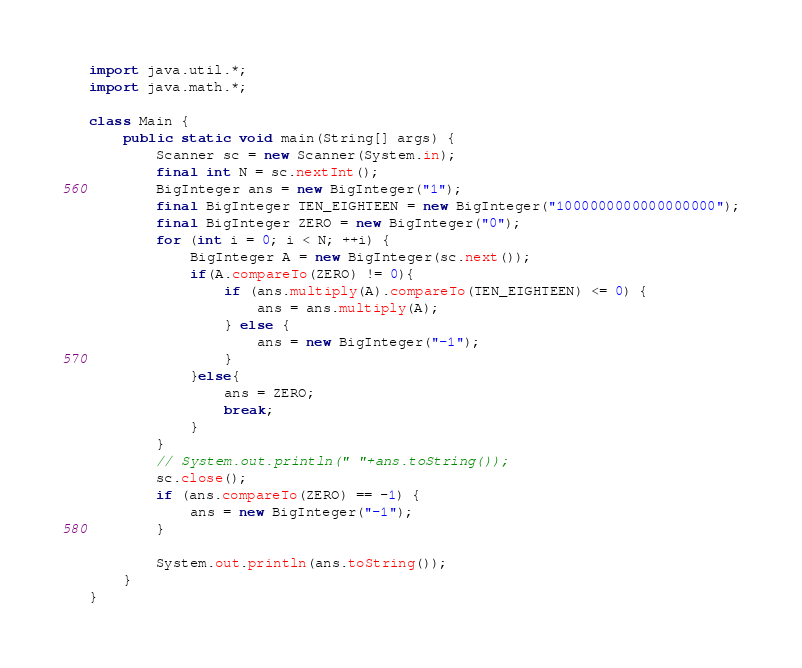Convert code to text. <code><loc_0><loc_0><loc_500><loc_500><_Java_>import java.util.*;
import java.math.*;

class Main {
	public static void main(String[] args) {
		Scanner sc = new Scanner(System.in);
		final int N = sc.nextInt();
		BigInteger ans = new BigInteger("1");
		final BigInteger TEN_EIGHTEEN = new BigInteger("1000000000000000000");
		final BigInteger ZERO = new BigInteger("0");
		for (int i = 0; i < N; ++i) {
			BigInteger A = new BigInteger(sc.next());
			if(A.compareTo(ZERO) != 0){
				if (ans.multiply(A).compareTo(TEN_EIGHTEEN) <= 0) {
					ans = ans.multiply(A);
				} else {
					ans = new BigInteger("-1");
				}
			}else{
				ans = ZERO;
				break;
			}
		}
		// System.out.println(" "+ans.toString());
		sc.close();
		if (ans.compareTo(ZERO) == -1) {
			ans = new BigInteger("-1");
		}

		System.out.println(ans.toString());
	}
}
</code> 